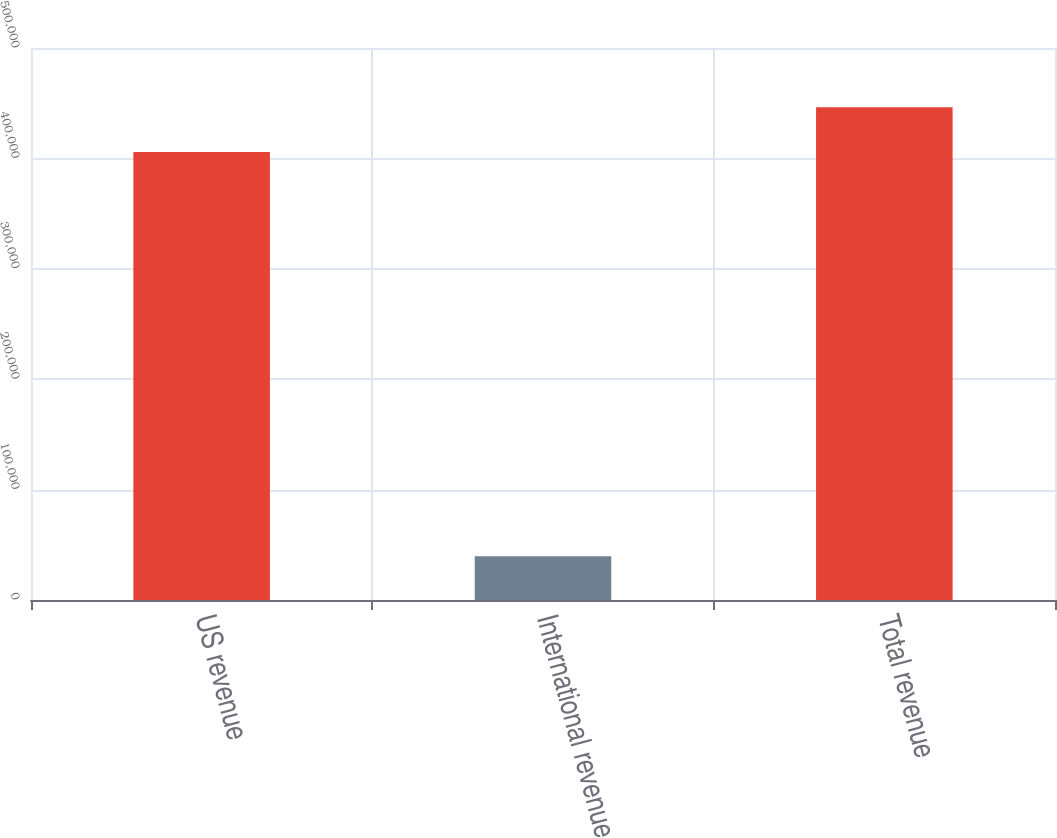Convert chart. <chart><loc_0><loc_0><loc_500><loc_500><bar_chart><fcel>US revenue<fcel>International revenue<fcel>Total revenue<nl><fcel>405781<fcel>39523<fcel>446359<nl></chart> 